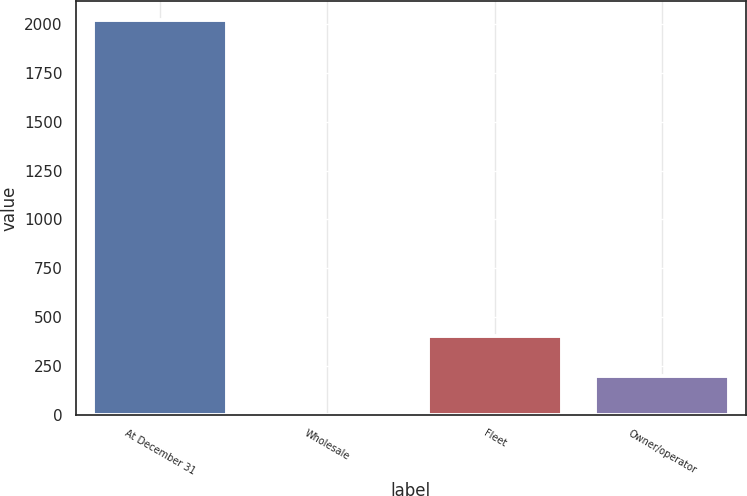Convert chart to OTSL. <chart><loc_0><loc_0><loc_500><loc_500><bar_chart><fcel>At December 31<fcel>Wholesale<fcel>Fleet<fcel>Owner/operator<nl><fcel>2017<fcel>0.1<fcel>403.48<fcel>201.79<nl></chart> 